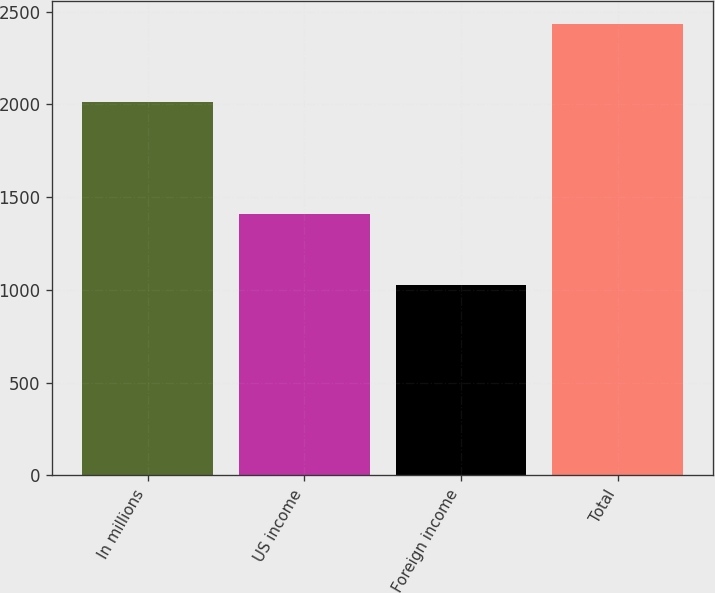Convert chart. <chart><loc_0><loc_0><loc_500><loc_500><bar_chart><fcel>In millions<fcel>US income<fcel>Foreign income<fcel>Total<nl><fcel>2014<fcel>1407<fcel>1027<fcel>2434<nl></chart> 